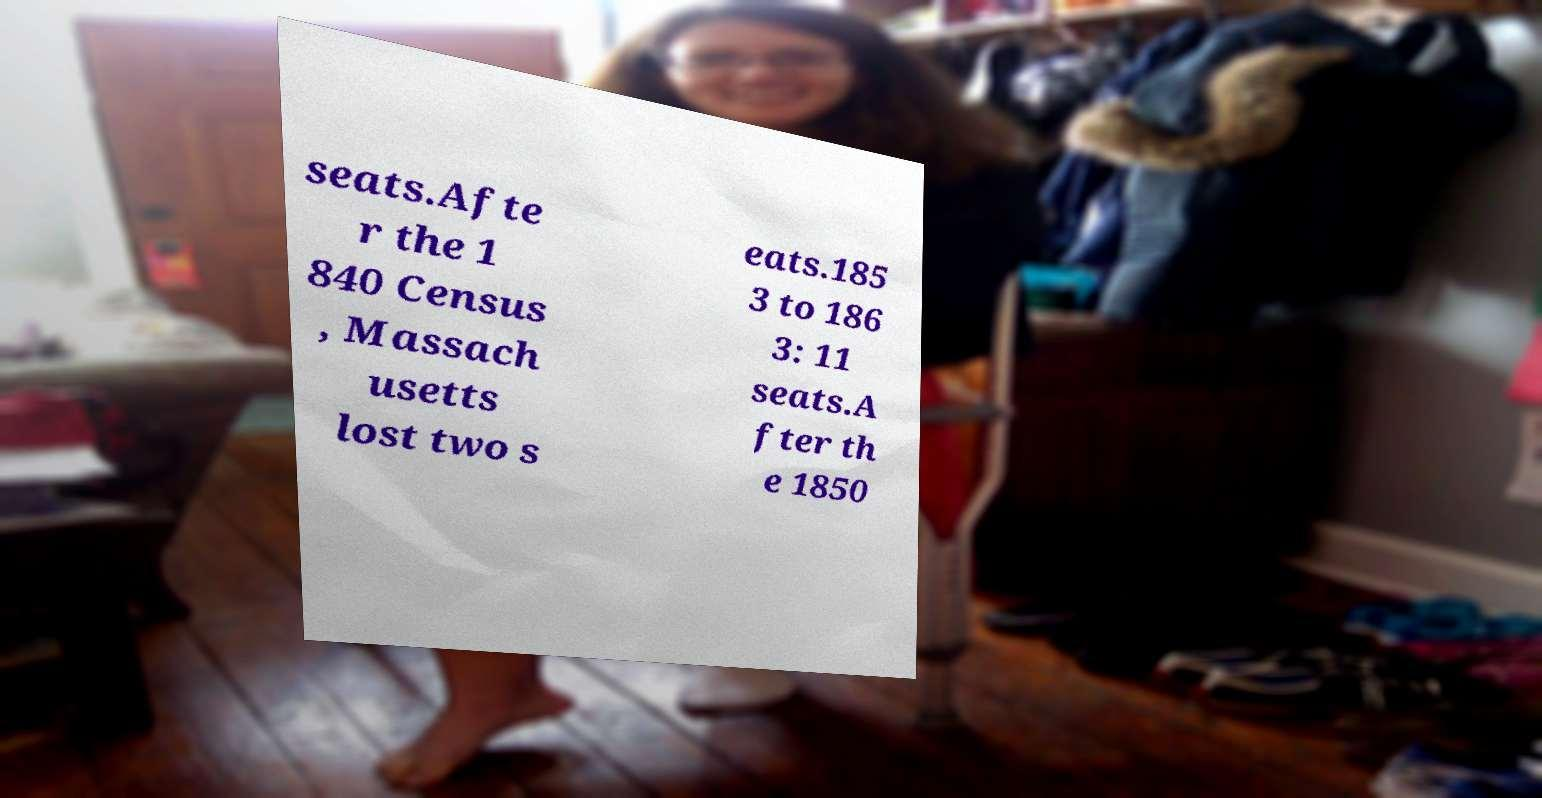Could you extract and type out the text from this image? seats.Afte r the 1 840 Census , Massach usetts lost two s eats.185 3 to 186 3: 11 seats.A fter th e 1850 